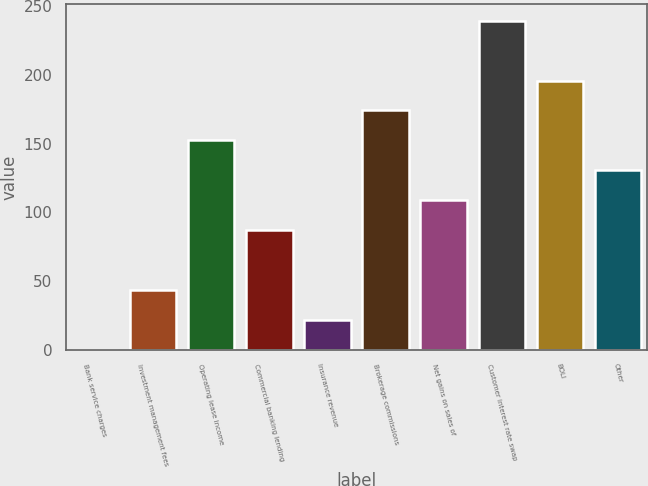Convert chart. <chart><loc_0><loc_0><loc_500><loc_500><bar_chart><fcel>Bank service charges<fcel>Investment management fees<fcel>Operating lease income<fcel>Commercial banking lending<fcel>Insurance revenue<fcel>Brokerage commissions<fcel>Net gains on sales of<fcel>Customer interest rate swap<fcel>BOLI<fcel>Other<nl><fcel>0.1<fcel>43.6<fcel>152.35<fcel>87.1<fcel>21.85<fcel>174.1<fcel>108.85<fcel>239.35<fcel>195.85<fcel>130.6<nl></chart> 